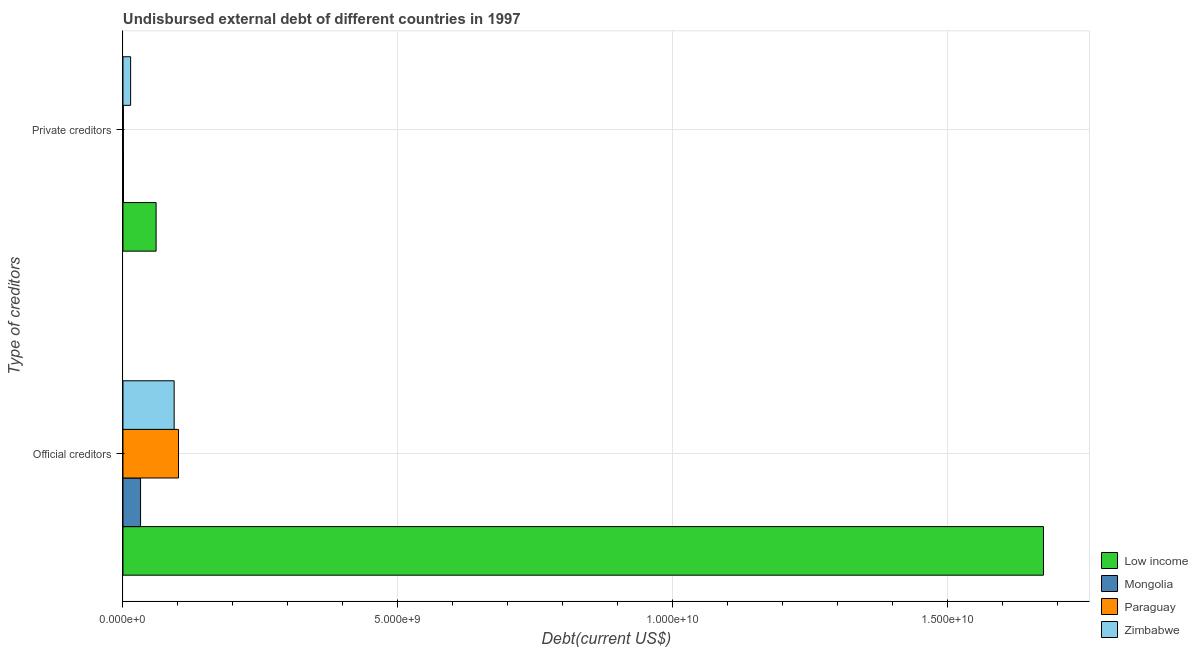How many different coloured bars are there?
Keep it short and to the point. 4. How many groups of bars are there?
Provide a short and direct response. 2. Are the number of bars on each tick of the Y-axis equal?
Make the answer very short. Yes. What is the label of the 1st group of bars from the top?
Provide a short and direct response. Private creditors. What is the undisbursed external debt of official creditors in Paraguay?
Your answer should be compact. 1.01e+09. Across all countries, what is the maximum undisbursed external debt of official creditors?
Provide a succinct answer. 1.67e+1. Across all countries, what is the minimum undisbursed external debt of private creditors?
Your answer should be very brief. 7.72e+06. In which country was the undisbursed external debt of official creditors maximum?
Provide a succinct answer. Low income. In which country was the undisbursed external debt of private creditors minimum?
Your answer should be very brief. Paraguay. What is the total undisbursed external debt of official creditors in the graph?
Give a very brief answer. 1.90e+1. What is the difference between the undisbursed external debt of private creditors in Mongolia and that in Zimbabwe?
Offer a very short reply. -1.30e+08. What is the difference between the undisbursed external debt of private creditors in Zimbabwe and the undisbursed external debt of official creditors in Mongolia?
Your response must be concise. -1.81e+08. What is the average undisbursed external debt of official creditors per country?
Make the answer very short. 4.75e+09. What is the difference between the undisbursed external debt of private creditors and undisbursed external debt of official creditors in Low income?
Give a very brief answer. -1.61e+1. In how many countries, is the undisbursed external debt of private creditors greater than 10000000000 US$?
Your answer should be very brief. 0. What is the ratio of the undisbursed external debt of official creditors in Mongolia to that in Paraguay?
Keep it short and to the point. 0.32. Is the undisbursed external debt of official creditors in Paraguay less than that in Zimbabwe?
Your response must be concise. No. In how many countries, is the undisbursed external debt of official creditors greater than the average undisbursed external debt of official creditors taken over all countries?
Your response must be concise. 1. What does the 2nd bar from the top in Private creditors represents?
Offer a terse response. Paraguay. How many bars are there?
Your answer should be compact. 8. What is the difference between two consecutive major ticks on the X-axis?
Give a very brief answer. 5.00e+09. Does the graph contain any zero values?
Ensure brevity in your answer.  No. Does the graph contain grids?
Give a very brief answer. Yes. Where does the legend appear in the graph?
Give a very brief answer. Bottom right. How are the legend labels stacked?
Offer a terse response. Vertical. What is the title of the graph?
Your answer should be compact. Undisbursed external debt of different countries in 1997. What is the label or title of the X-axis?
Your response must be concise. Debt(current US$). What is the label or title of the Y-axis?
Make the answer very short. Type of creditors. What is the Debt(current US$) of Low income in Official creditors?
Make the answer very short. 1.67e+1. What is the Debt(current US$) in Mongolia in Official creditors?
Make the answer very short. 3.20e+08. What is the Debt(current US$) in Paraguay in Official creditors?
Offer a terse response. 1.01e+09. What is the Debt(current US$) in Zimbabwe in Official creditors?
Make the answer very short. 9.31e+08. What is the Debt(current US$) in Low income in Private creditors?
Provide a succinct answer. 6.03e+08. What is the Debt(current US$) in Mongolia in Private creditors?
Provide a succinct answer. 9.36e+06. What is the Debt(current US$) of Paraguay in Private creditors?
Your answer should be very brief. 7.72e+06. What is the Debt(current US$) in Zimbabwe in Private creditors?
Your answer should be very brief. 1.39e+08. Across all Type of creditors, what is the maximum Debt(current US$) of Low income?
Provide a succinct answer. 1.67e+1. Across all Type of creditors, what is the maximum Debt(current US$) in Mongolia?
Your answer should be very brief. 3.20e+08. Across all Type of creditors, what is the maximum Debt(current US$) of Paraguay?
Your answer should be very brief. 1.01e+09. Across all Type of creditors, what is the maximum Debt(current US$) in Zimbabwe?
Keep it short and to the point. 9.31e+08. Across all Type of creditors, what is the minimum Debt(current US$) of Low income?
Give a very brief answer. 6.03e+08. Across all Type of creditors, what is the minimum Debt(current US$) of Mongolia?
Offer a very short reply. 9.36e+06. Across all Type of creditors, what is the minimum Debt(current US$) of Paraguay?
Provide a succinct answer. 7.72e+06. Across all Type of creditors, what is the minimum Debt(current US$) in Zimbabwe?
Your response must be concise. 1.39e+08. What is the total Debt(current US$) of Low income in the graph?
Offer a terse response. 1.74e+1. What is the total Debt(current US$) of Mongolia in the graph?
Offer a very short reply. 3.29e+08. What is the total Debt(current US$) of Paraguay in the graph?
Ensure brevity in your answer.  1.02e+09. What is the total Debt(current US$) in Zimbabwe in the graph?
Keep it short and to the point. 1.07e+09. What is the difference between the Debt(current US$) of Low income in Official creditors and that in Private creditors?
Provide a succinct answer. 1.61e+1. What is the difference between the Debt(current US$) in Mongolia in Official creditors and that in Private creditors?
Make the answer very short. 3.11e+08. What is the difference between the Debt(current US$) in Paraguay in Official creditors and that in Private creditors?
Your response must be concise. 1.00e+09. What is the difference between the Debt(current US$) of Zimbabwe in Official creditors and that in Private creditors?
Provide a short and direct response. 7.92e+08. What is the difference between the Debt(current US$) in Low income in Official creditors and the Debt(current US$) in Mongolia in Private creditors?
Make the answer very short. 1.67e+1. What is the difference between the Debt(current US$) in Low income in Official creditors and the Debt(current US$) in Paraguay in Private creditors?
Offer a terse response. 1.67e+1. What is the difference between the Debt(current US$) of Low income in Official creditors and the Debt(current US$) of Zimbabwe in Private creditors?
Keep it short and to the point. 1.66e+1. What is the difference between the Debt(current US$) of Mongolia in Official creditors and the Debt(current US$) of Paraguay in Private creditors?
Provide a short and direct response. 3.12e+08. What is the difference between the Debt(current US$) in Mongolia in Official creditors and the Debt(current US$) in Zimbabwe in Private creditors?
Your response must be concise. 1.81e+08. What is the difference between the Debt(current US$) of Paraguay in Official creditors and the Debt(current US$) of Zimbabwe in Private creditors?
Keep it short and to the point. 8.71e+08. What is the average Debt(current US$) of Low income per Type of creditors?
Offer a terse response. 8.68e+09. What is the average Debt(current US$) of Mongolia per Type of creditors?
Provide a succinct answer. 1.65e+08. What is the average Debt(current US$) in Paraguay per Type of creditors?
Your answer should be compact. 5.09e+08. What is the average Debt(current US$) in Zimbabwe per Type of creditors?
Ensure brevity in your answer.  5.35e+08. What is the difference between the Debt(current US$) of Low income and Debt(current US$) of Mongolia in Official creditors?
Keep it short and to the point. 1.64e+1. What is the difference between the Debt(current US$) of Low income and Debt(current US$) of Paraguay in Official creditors?
Provide a succinct answer. 1.57e+1. What is the difference between the Debt(current US$) in Low income and Debt(current US$) in Zimbabwe in Official creditors?
Your response must be concise. 1.58e+1. What is the difference between the Debt(current US$) in Mongolia and Debt(current US$) in Paraguay in Official creditors?
Provide a short and direct response. -6.90e+08. What is the difference between the Debt(current US$) in Mongolia and Debt(current US$) in Zimbabwe in Official creditors?
Your response must be concise. -6.11e+08. What is the difference between the Debt(current US$) in Paraguay and Debt(current US$) in Zimbabwe in Official creditors?
Keep it short and to the point. 7.93e+07. What is the difference between the Debt(current US$) in Low income and Debt(current US$) in Mongolia in Private creditors?
Provide a succinct answer. 5.93e+08. What is the difference between the Debt(current US$) in Low income and Debt(current US$) in Paraguay in Private creditors?
Give a very brief answer. 5.95e+08. What is the difference between the Debt(current US$) in Low income and Debt(current US$) in Zimbabwe in Private creditors?
Offer a very short reply. 4.63e+08. What is the difference between the Debt(current US$) in Mongolia and Debt(current US$) in Paraguay in Private creditors?
Ensure brevity in your answer.  1.64e+06. What is the difference between the Debt(current US$) in Mongolia and Debt(current US$) in Zimbabwe in Private creditors?
Your answer should be very brief. -1.30e+08. What is the difference between the Debt(current US$) in Paraguay and Debt(current US$) in Zimbabwe in Private creditors?
Make the answer very short. -1.31e+08. What is the ratio of the Debt(current US$) in Low income in Official creditors to that in Private creditors?
Your response must be concise. 27.79. What is the ratio of the Debt(current US$) in Mongolia in Official creditors to that in Private creditors?
Offer a terse response. 34.21. What is the ratio of the Debt(current US$) in Paraguay in Official creditors to that in Private creditors?
Make the answer very short. 130.98. What is the ratio of the Debt(current US$) in Zimbabwe in Official creditors to that in Private creditors?
Your answer should be compact. 6.69. What is the difference between the highest and the second highest Debt(current US$) of Low income?
Make the answer very short. 1.61e+1. What is the difference between the highest and the second highest Debt(current US$) of Mongolia?
Make the answer very short. 3.11e+08. What is the difference between the highest and the second highest Debt(current US$) in Paraguay?
Ensure brevity in your answer.  1.00e+09. What is the difference between the highest and the second highest Debt(current US$) in Zimbabwe?
Your response must be concise. 7.92e+08. What is the difference between the highest and the lowest Debt(current US$) in Low income?
Ensure brevity in your answer.  1.61e+1. What is the difference between the highest and the lowest Debt(current US$) in Mongolia?
Your answer should be very brief. 3.11e+08. What is the difference between the highest and the lowest Debt(current US$) of Paraguay?
Keep it short and to the point. 1.00e+09. What is the difference between the highest and the lowest Debt(current US$) in Zimbabwe?
Offer a terse response. 7.92e+08. 